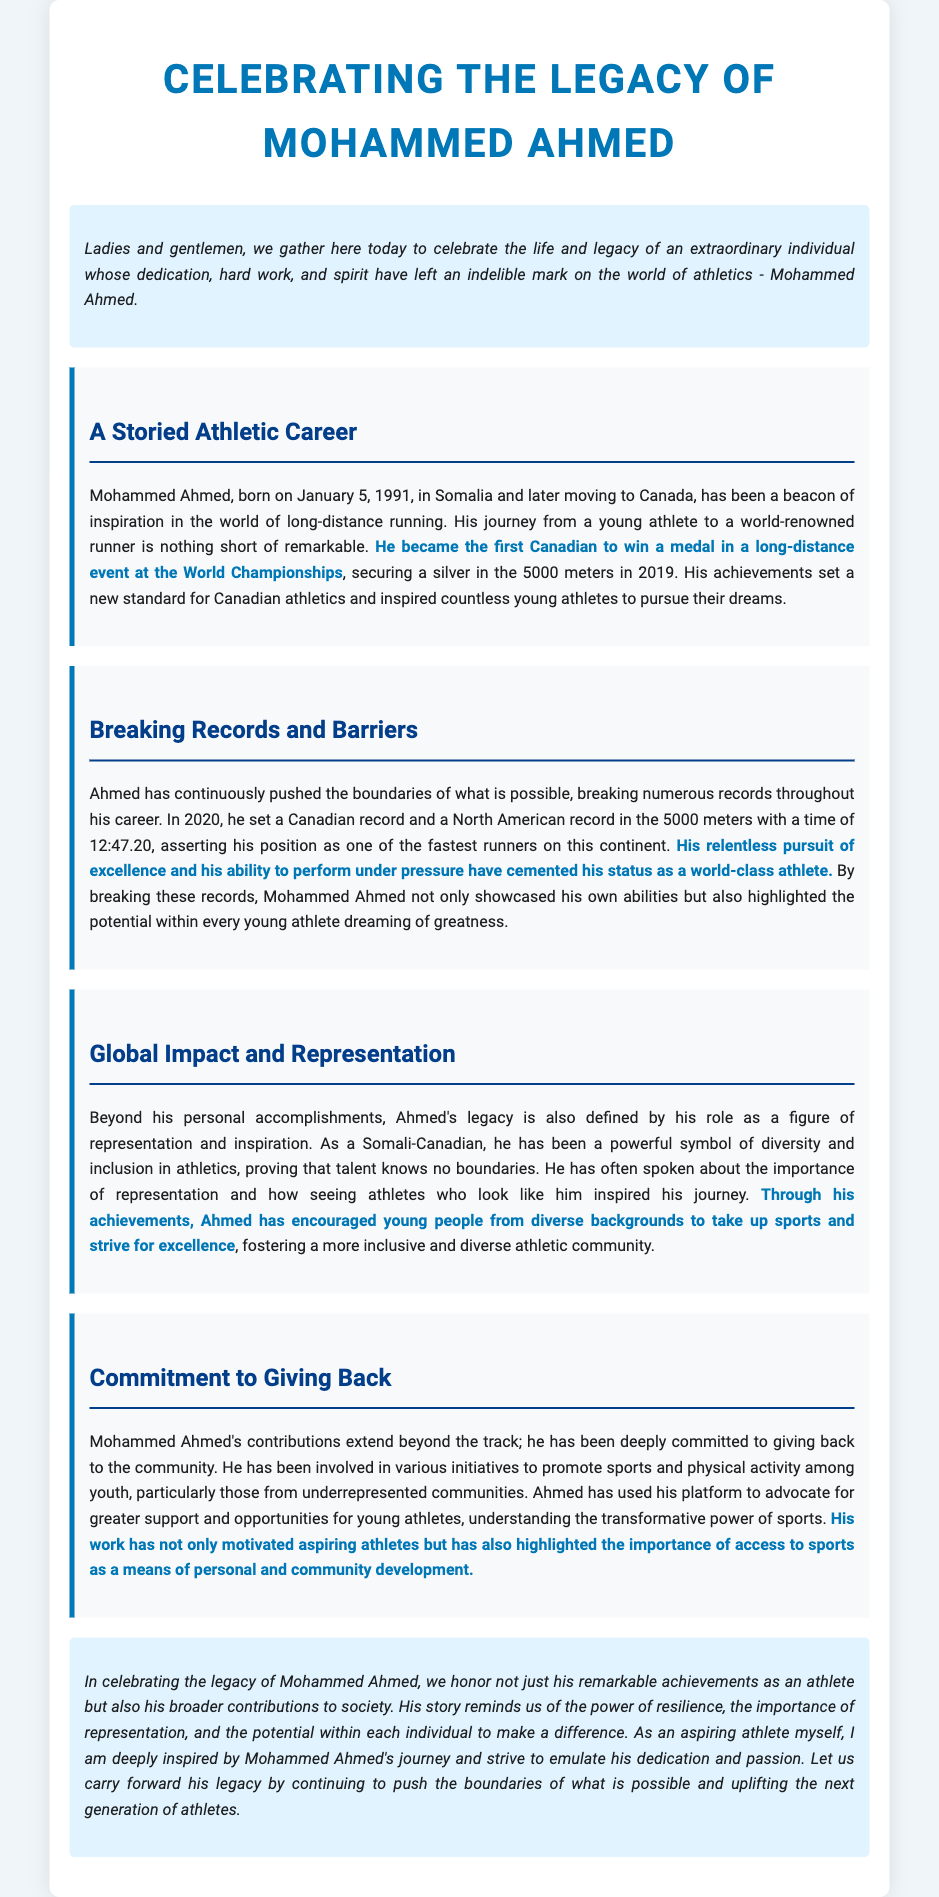What is Mohammed Ahmed's birth date? Mohammed Ahmed was born on January 5, 1991, as stated in the document.
Answer: January 5, 1991 What medal did Mohammed Ahmed win at the World Championships? The document mentions that he secured a silver medal in the 5000 meters at the World Championships in 2019.
Answer: Silver What record did Ahmed set in 2020? The document states that he set a Canadian and North American record in the 5000 meters with a time of 12:47.20.
Answer: 12:47.20 What is Ahmed's nationality? The document identifies Mohammed Ahmed as a Somali-Canadian.
Answer: Somali-Canadian What is one aspect of Ahmed's legacy mentioned in the document? The document discusses his role as a figure of representation and inspiration.
Answer: Representation How has Ahmed contributed to community initiatives? The document notes that he has been involved in promoting sports and physical activity among youth, particularly in underrepresented communities.
Answer: Promoting sports What does the eulogy emphasize about the importance of representation? The document states that seeing athletes who look like them inspired his journey, highlighting how representation encourages participation in sports.
Answer: Encourages participation What does the conclusion of the eulogy call for? The eulogy concludes with a call to carry forward Ahmed's legacy by uplifting the next generation of athletes.
Answer: Uplifting the next generation 